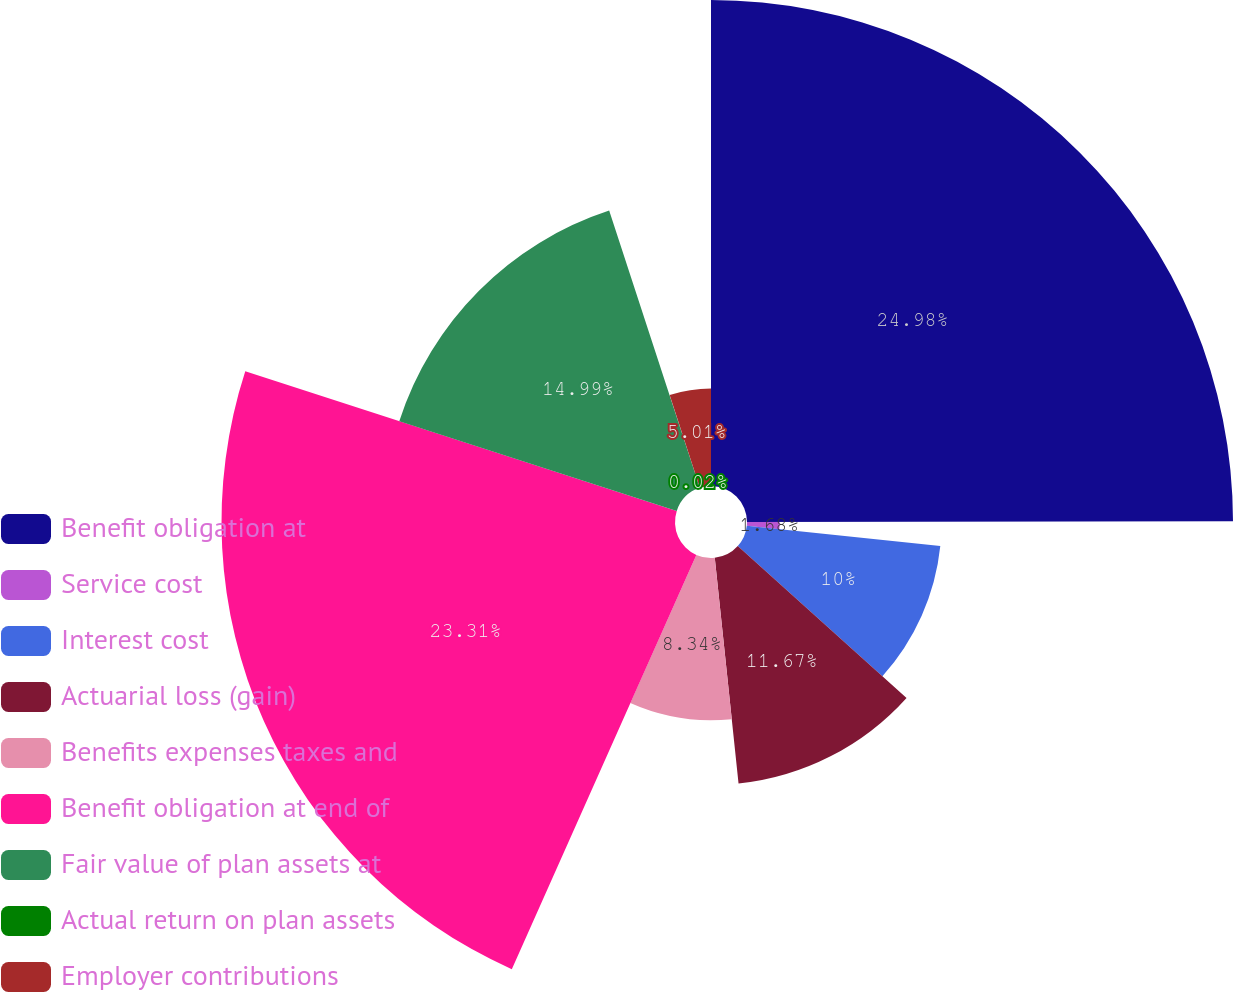Convert chart to OTSL. <chart><loc_0><loc_0><loc_500><loc_500><pie_chart><fcel>Benefit obligation at<fcel>Service cost<fcel>Interest cost<fcel>Actuarial loss (gain)<fcel>Benefits expenses taxes and<fcel>Benefit obligation at end of<fcel>Fair value of plan assets at<fcel>Actual return on plan assets<fcel>Employer contributions<nl><fcel>24.98%<fcel>1.68%<fcel>10.0%<fcel>11.67%<fcel>8.34%<fcel>23.31%<fcel>14.99%<fcel>0.02%<fcel>5.01%<nl></chart> 